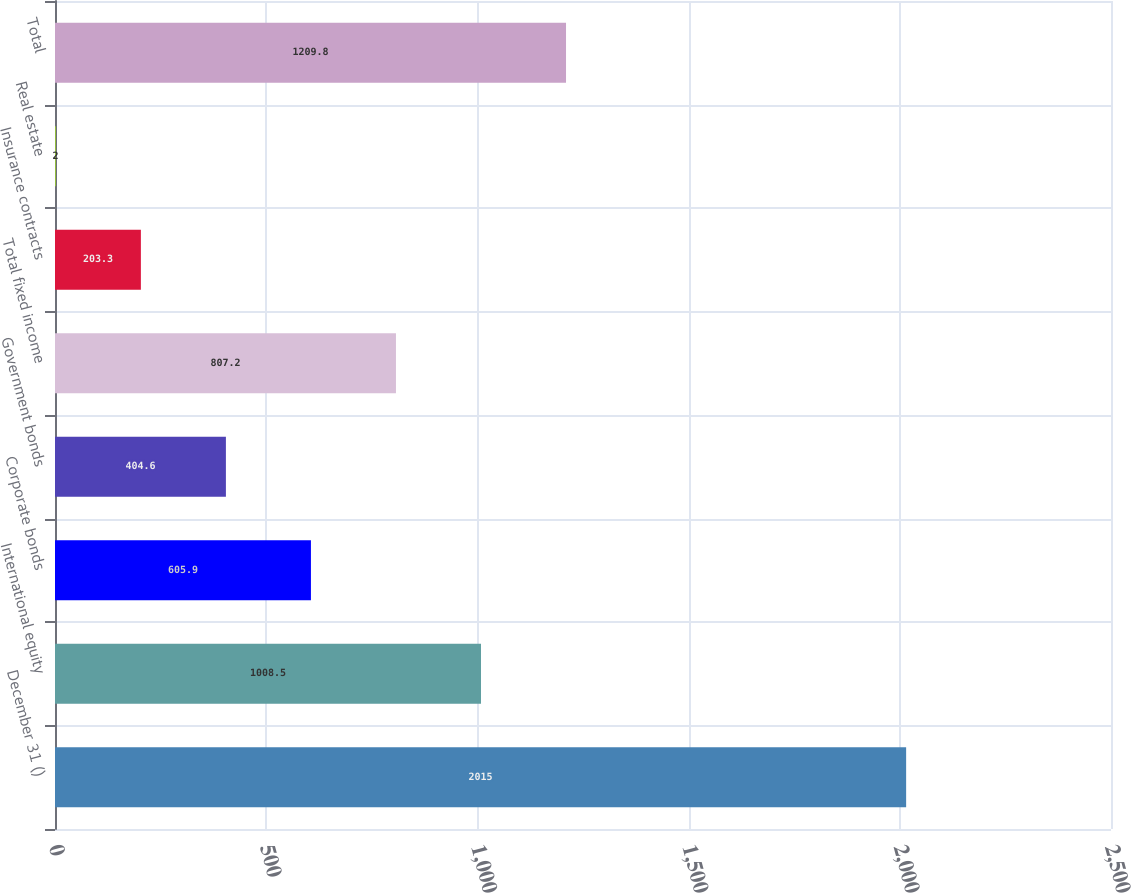Convert chart to OTSL. <chart><loc_0><loc_0><loc_500><loc_500><bar_chart><fcel>December 31 ()<fcel>International equity<fcel>Corporate bonds<fcel>Government bonds<fcel>Total fixed income<fcel>Insurance contracts<fcel>Real estate<fcel>Total<nl><fcel>2015<fcel>1008.5<fcel>605.9<fcel>404.6<fcel>807.2<fcel>203.3<fcel>2<fcel>1209.8<nl></chart> 